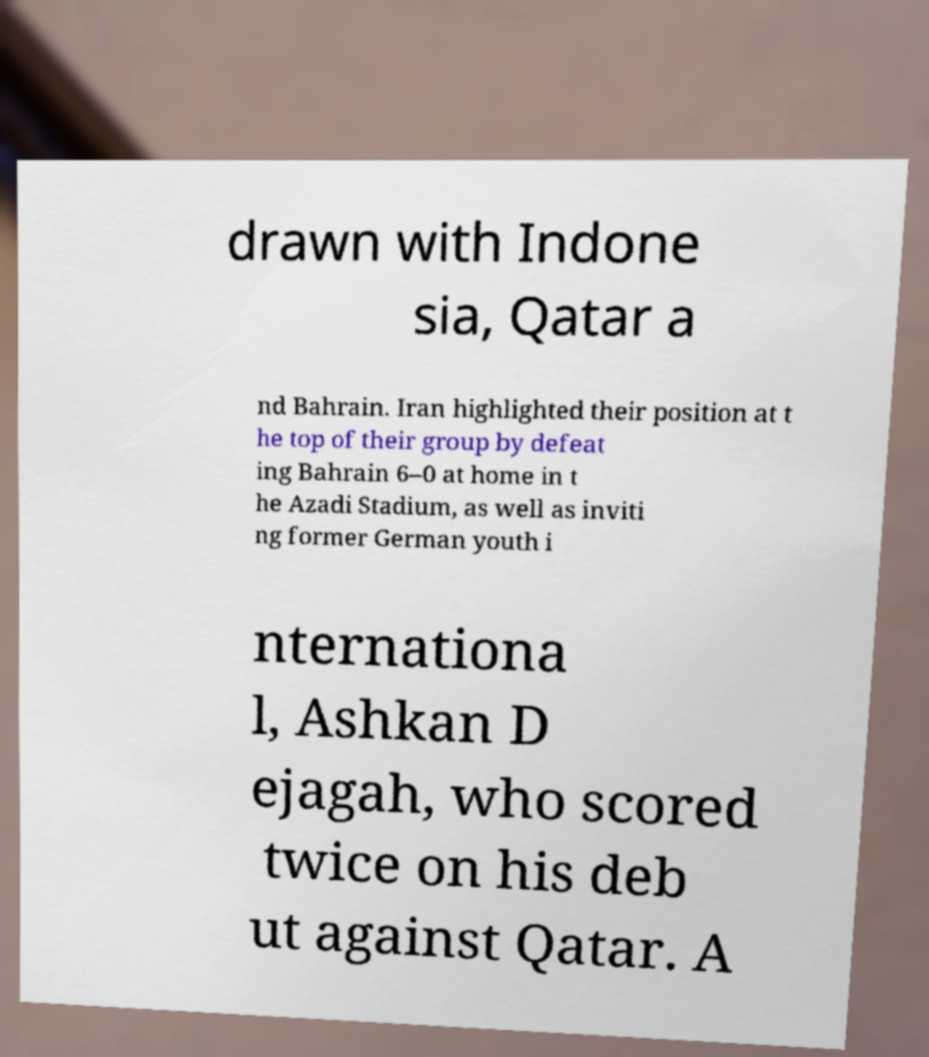Please identify and transcribe the text found in this image. drawn with Indone sia, Qatar a nd Bahrain. Iran highlighted their position at t he top of their group by defeat ing Bahrain 6–0 at home in t he Azadi Stadium, as well as inviti ng former German youth i nternationa l, Ashkan D ejagah, who scored twice on his deb ut against Qatar. A 